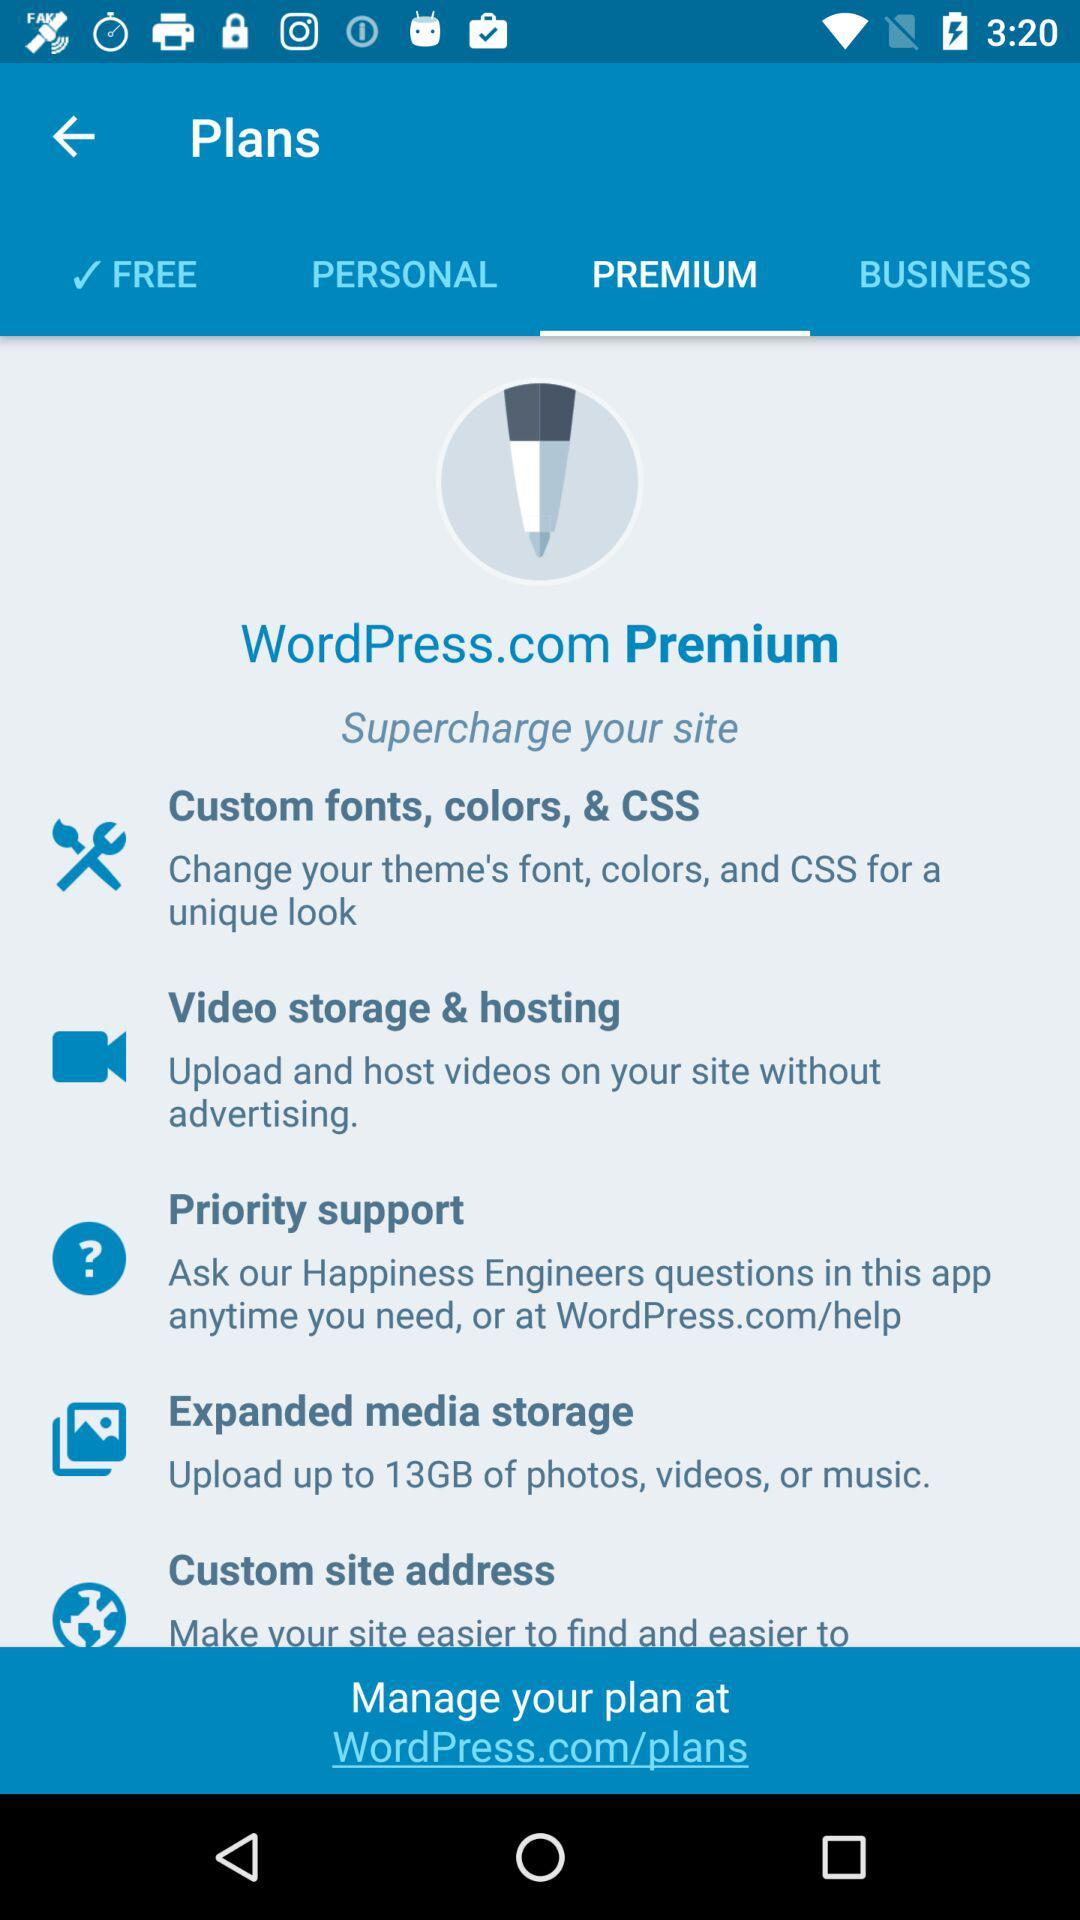Which tab is selected? The selected tab is "PREMIUM". 